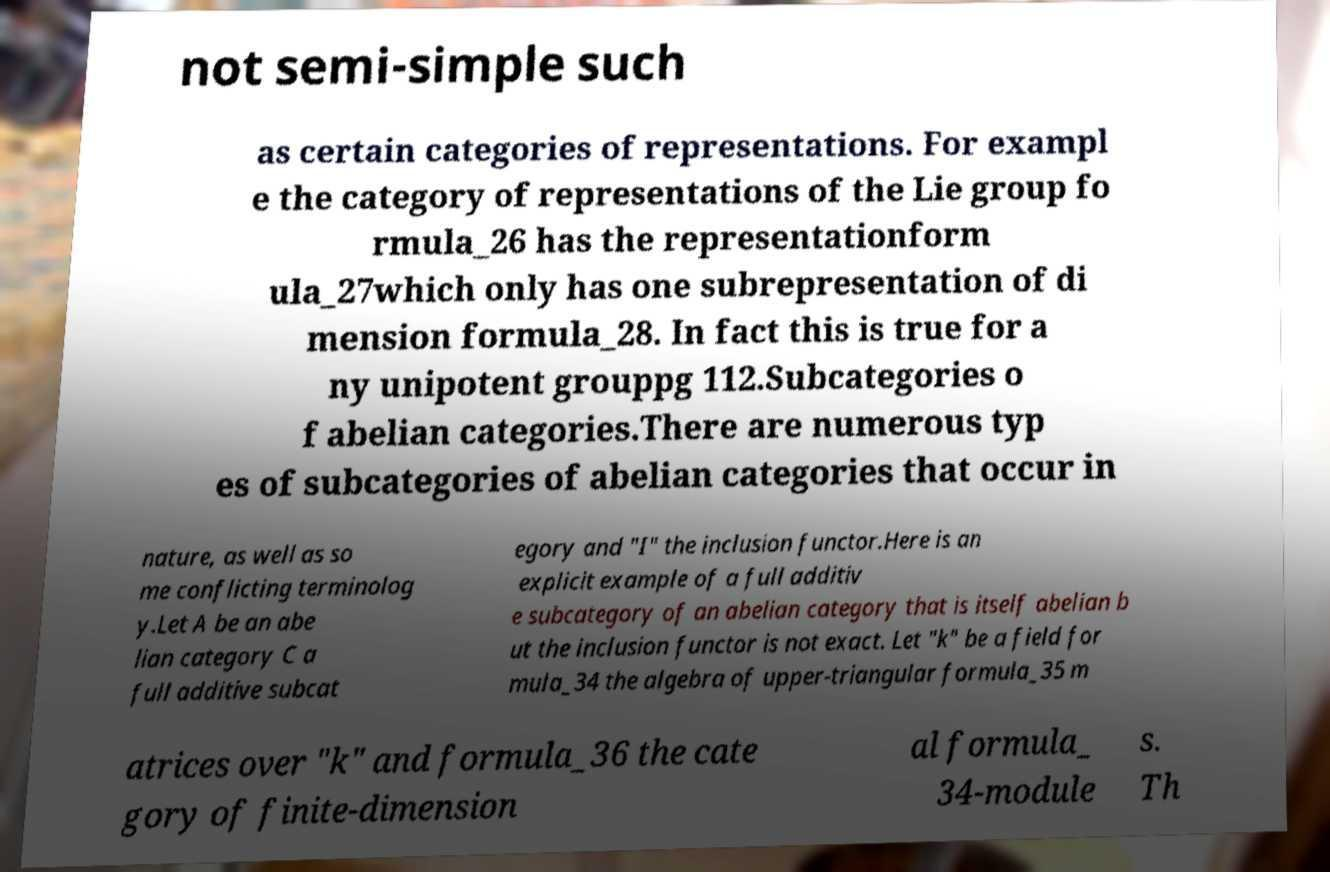There's text embedded in this image that I need extracted. Can you transcribe it verbatim? not semi-simple such as certain categories of representations. For exampl e the category of representations of the Lie group fo rmula_26 has the representationform ula_27which only has one subrepresentation of di mension formula_28. In fact this is true for a ny unipotent grouppg 112.Subcategories o f abelian categories.There are numerous typ es of subcategories of abelian categories that occur in nature, as well as so me conflicting terminolog y.Let A be an abe lian category C a full additive subcat egory and "I" the inclusion functor.Here is an explicit example of a full additiv e subcategory of an abelian category that is itself abelian b ut the inclusion functor is not exact. Let "k" be a field for mula_34 the algebra of upper-triangular formula_35 m atrices over "k" and formula_36 the cate gory of finite-dimension al formula_ 34-module s. Th 